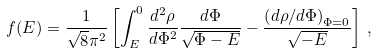<formula> <loc_0><loc_0><loc_500><loc_500>f ( E ) = \frac { 1 } { \sqrt { 8 } \pi ^ { 2 } } \left [ \int _ { E } ^ { 0 } \frac { d ^ { 2 } \rho } { d \Phi ^ { 2 } } \frac { d \Phi } { \sqrt { \Phi - E } } - \frac { \left ( { d \rho } / { d \Phi } \right ) _ { \Phi = 0 } } { \sqrt { - E } } \right ] \, ,</formula> 